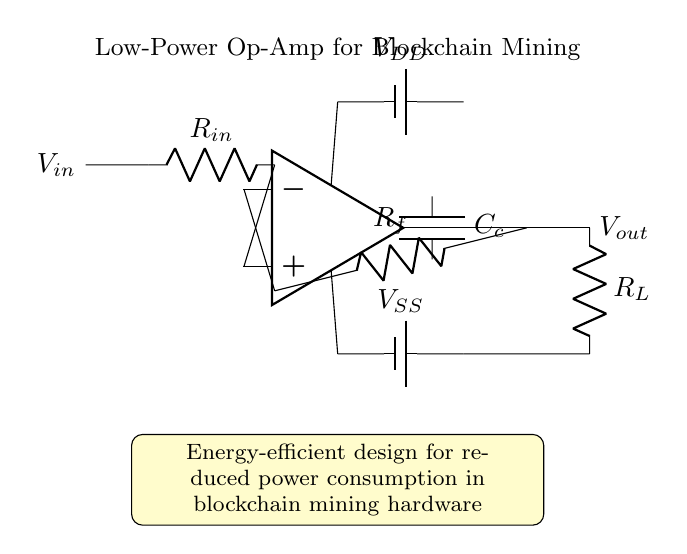What type of operational amplifier is used in this circuit? The circuit specifically mentions "Low-Power Op-Amp," indicating that it is designed for energy efficiency, which is crucial for applications like blockchain mining.
Answer: Low-Power Op-Amp What is the value of the feedback resistor in the circuit? The diagram labels the feedback resistor as R_f, which suggests it can be selected according to design requirements, but a specific value is not provided in the diagram itself.
Answer: R_f What is the primary function of the capacitor in this circuit? The capacitor is labeled as C_c, which stands for compensation capacitor, typically used to stabilize the op-amp and improve bandwidth; thus, its primary function is to ensure stability in the circuit.
Answer: Stabilization What is the significance of the yellow box in the diagram? The yellow box provides an energy-efficiency note that emphasizes the importance of reducing power consumption in the context of blockchain mining hardware, highlighting the design goal.
Answer: Energy-efficient design How many power supply connections are indicated in the circuit? The circuit shows two power supply connections (V_DD and V_SS) for the operational amplifier, which are necessary for its operation.
Answer: Two What is the output load resistor labeled as in the circuit? The load resistor in the circuit is labeled as R_L, which typically serves as the load on the op-amp output, allowing for the measured performance of the amplifier.
Answer: R_L What is the input voltage labeled as in the diagram? The input voltage is shown as V_in in the circuit diagram, representing the signal that is fed into the operational amplifier for amplification.
Answer: V_in 